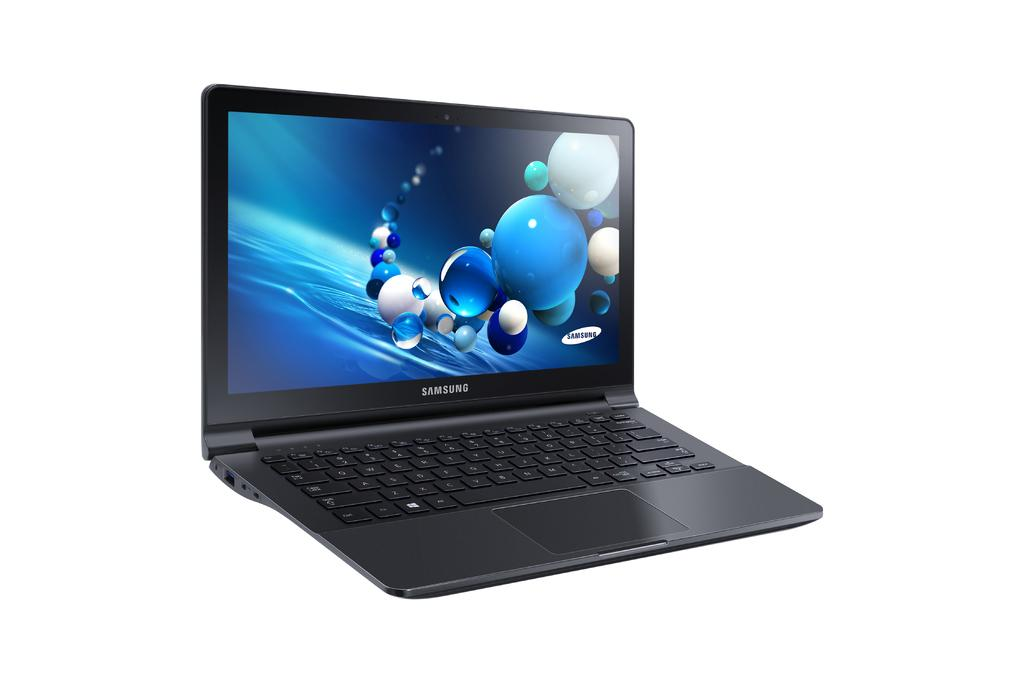<image>
Describe the image concisely. a picture of a black Samsung laptop with bubbles on the screen saver. 